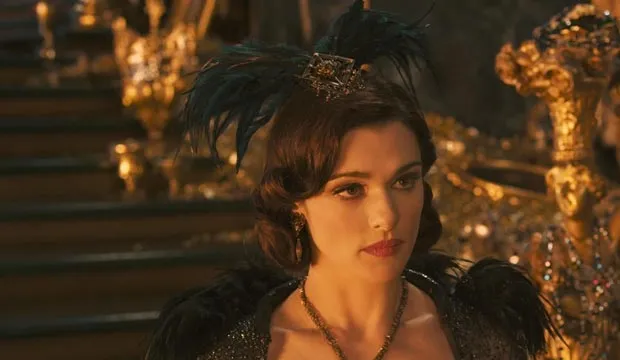What kind of magical abilities does Evanora possess? Evanora possesses powerful magical abilities, including telekinesis, the ability to conjure and manipulate lightning, and an extensive knowledge of dark magic. She can cast powerful spells to control people and events to her advantage. Her magic comes with a deep understanding of ancient rituals and artifacts, making her a formidable and dangerous adversary in the land of Oz. 